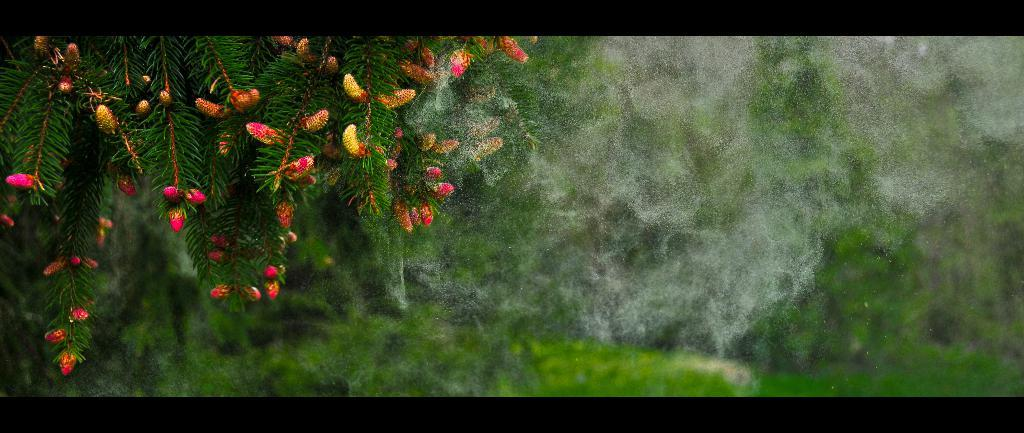What is the main object in the image? There is a tree in the image. Can you describe the background of the image? The background of the image is blurred. How many bites have been taken out of the pear in the image? There is no pear present in the image, only a tree. 